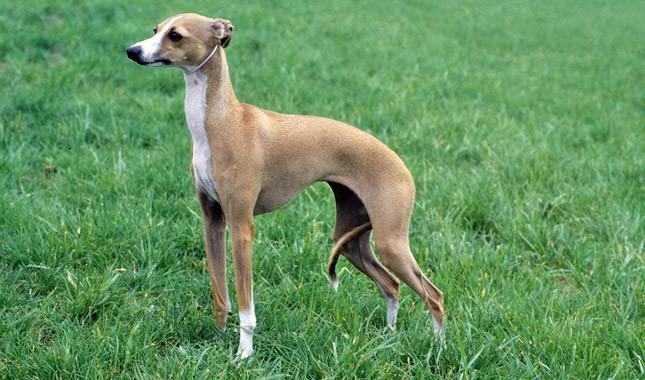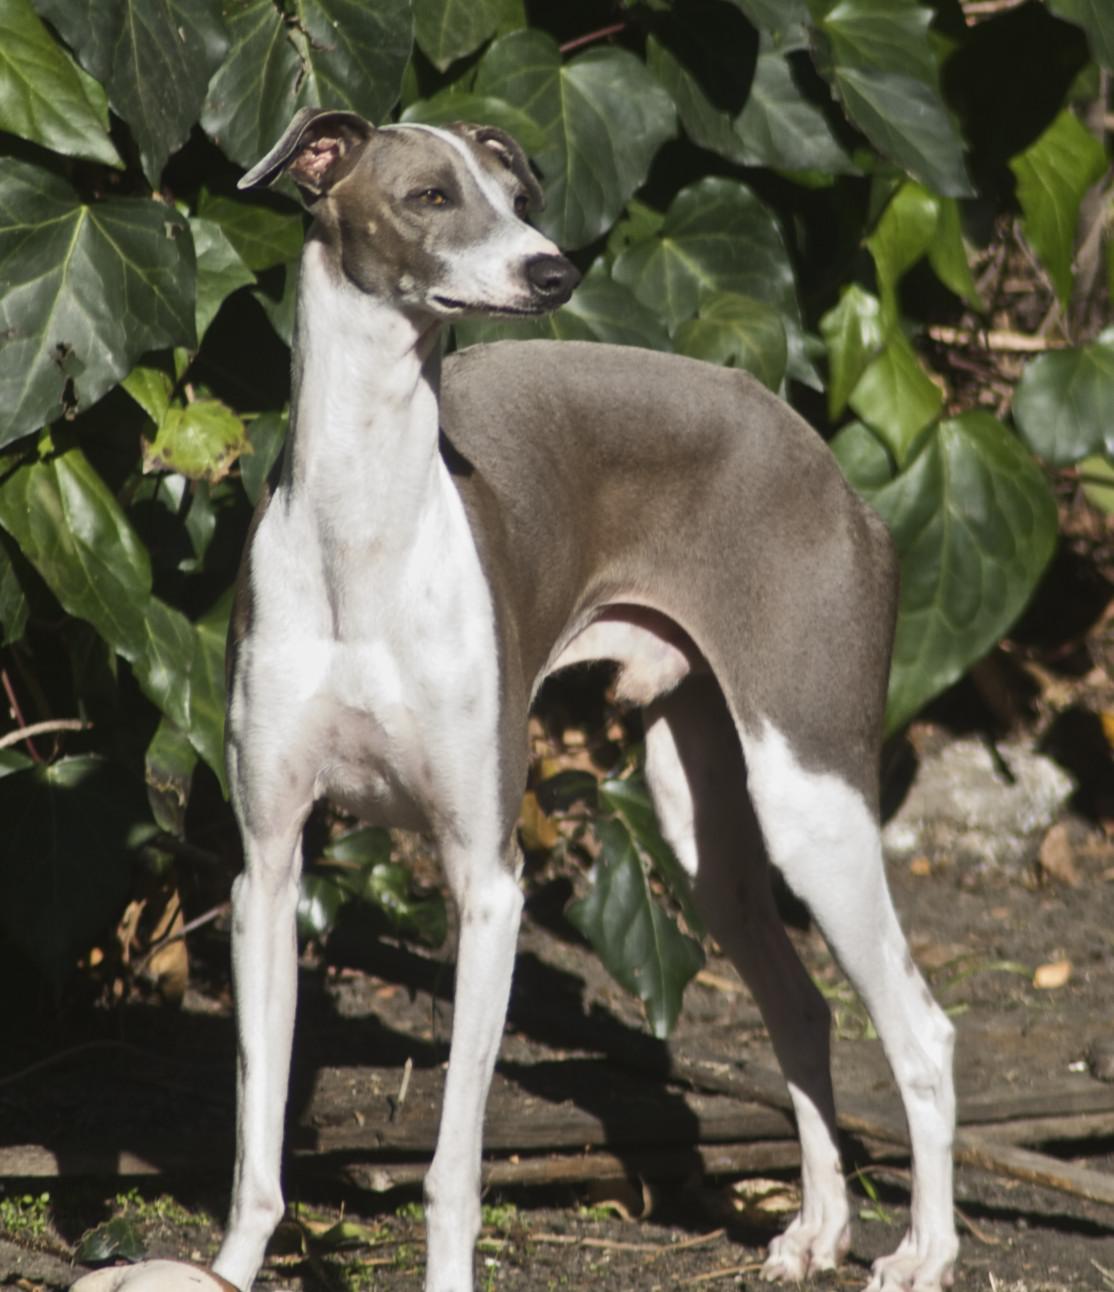The first image is the image on the left, the second image is the image on the right. For the images shown, is this caption "The right image shows a hound standing on thick green grass." true? Answer yes or no. No. 